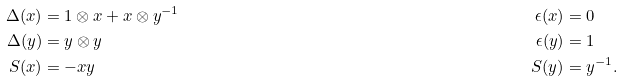Convert formula to latex. <formula><loc_0><loc_0><loc_500><loc_500>\Delta ( x ) & = 1 \otimes x + x \otimes y ^ { - 1 } & \epsilon ( x ) & = 0 \\ \Delta ( y ) & = y \otimes y & \epsilon ( y ) & = 1 \\ S ( x ) & = - x y & S ( y ) & = y ^ { - 1 } .</formula> 